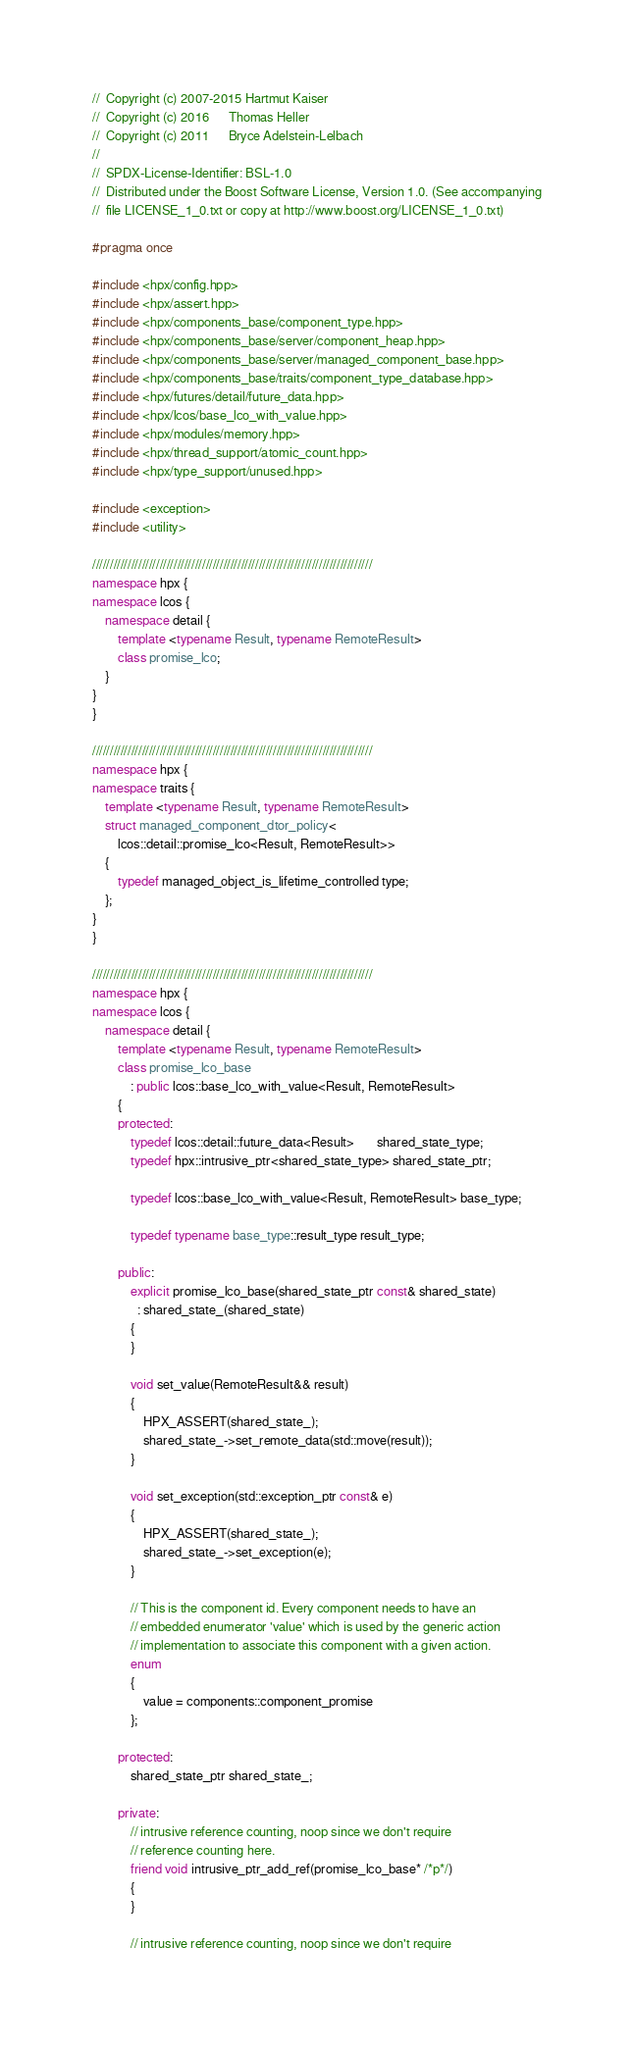<code> <loc_0><loc_0><loc_500><loc_500><_C++_>//  Copyright (c) 2007-2015 Hartmut Kaiser
//  Copyright (c) 2016      Thomas Heller
//  Copyright (c) 2011      Bryce Adelstein-Lelbach
//
//  SPDX-License-Identifier: BSL-1.0
//  Distributed under the Boost Software License, Version 1.0. (See accompanying
//  file LICENSE_1_0.txt or copy at http://www.boost.org/LICENSE_1_0.txt)

#pragma once

#include <hpx/config.hpp>
#include <hpx/assert.hpp>
#include <hpx/components_base/component_type.hpp>
#include <hpx/components_base/server/component_heap.hpp>
#include <hpx/components_base/server/managed_component_base.hpp>
#include <hpx/components_base/traits/component_type_database.hpp>
#include <hpx/futures/detail/future_data.hpp>
#include <hpx/lcos/base_lco_with_value.hpp>
#include <hpx/modules/memory.hpp>
#include <hpx/thread_support/atomic_count.hpp>
#include <hpx/type_support/unused.hpp>

#include <exception>
#include <utility>

///////////////////////////////////////////////////////////////////////////////
namespace hpx {
namespace lcos {
    namespace detail {
        template <typename Result, typename RemoteResult>
        class promise_lco;
    }
}
}

///////////////////////////////////////////////////////////////////////////////
namespace hpx {
namespace traits {
    template <typename Result, typename RemoteResult>
    struct managed_component_dtor_policy<
        lcos::detail::promise_lco<Result, RemoteResult>>
    {
        typedef managed_object_is_lifetime_controlled type;
    };
}
}

///////////////////////////////////////////////////////////////////////////////
namespace hpx {
namespace lcos {
    namespace detail {
        template <typename Result, typename RemoteResult>
        class promise_lco_base
            : public lcos::base_lco_with_value<Result, RemoteResult>
        {
        protected:
            typedef lcos::detail::future_data<Result>       shared_state_type;
            typedef hpx::intrusive_ptr<shared_state_type> shared_state_ptr;

            typedef lcos::base_lco_with_value<Result, RemoteResult> base_type;

            typedef typename base_type::result_type result_type;

        public:
            explicit promise_lco_base(shared_state_ptr const& shared_state)
              : shared_state_(shared_state)
            {
            }

            void set_value(RemoteResult&& result)
            {
                HPX_ASSERT(shared_state_);
                shared_state_->set_remote_data(std::move(result));
            }

            void set_exception(std::exception_ptr const& e)
            {
                HPX_ASSERT(shared_state_);
                shared_state_->set_exception(e);
            }

            // This is the component id. Every component needs to have an
            // embedded enumerator 'value' which is used by the generic action
            // implementation to associate this component with a given action.
            enum
            {
                value = components::component_promise
            };

        protected:
            shared_state_ptr shared_state_;

        private:
            // intrusive reference counting, noop since we don't require
            // reference counting here.
            friend void intrusive_ptr_add_ref(promise_lco_base* /*p*/)
            {
            }

            // intrusive reference counting, noop since we don't require</code> 